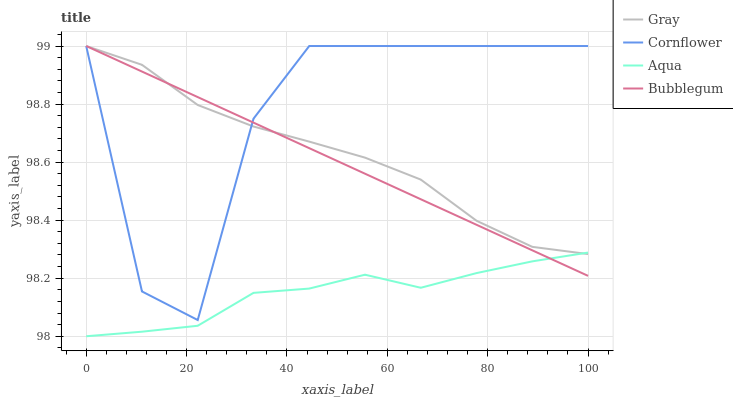Does Aqua have the minimum area under the curve?
Answer yes or no. Yes. Does Cornflower have the maximum area under the curve?
Answer yes or no. Yes. Does Bubblegum have the minimum area under the curve?
Answer yes or no. No. Does Bubblegum have the maximum area under the curve?
Answer yes or no. No. Is Bubblegum the smoothest?
Answer yes or no. Yes. Is Cornflower the roughest?
Answer yes or no. Yes. Is Aqua the smoothest?
Answer yes or no. No. Is Aqua the roughest?
Answer yes or no. No. Does Aqua have the lowest value?
Answer yes or no. Yes. Does Bubblegum have the lowest value?
Answer yes or no. No. Does Cornflower have the highest value?
Answer yes or no. Yes. Does Aqua have the highest value?
Answer yes or no. No. Is Aqua less than Cornflower?
Answer yes or no. Yes. Is Cornflower greater than Aqua?
Answer yes or no. Yes. Does Cornflower intersect Gray?
Answer yes or no. Yes. Is Cornflower less than Gray?
Answer yes or no. No. Is Cornflower greater than Gray?
Answer yes or no. No. Does Aqua intersect Cornflower?
Answer yes or no. No. 